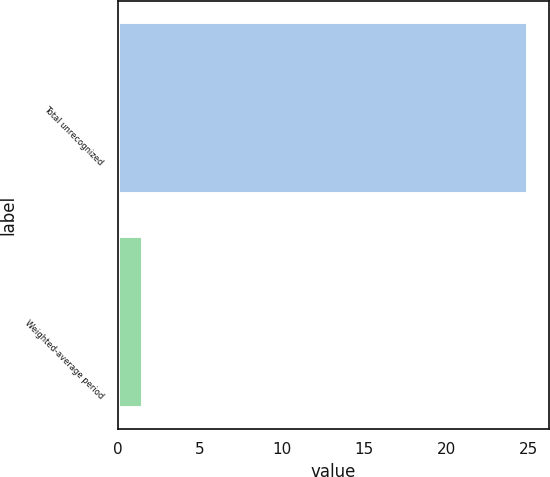Convert chart. <chart><loc_0><loc_0><loc_500><loc_500><bar_chart><fcel>Total unrecognized<fcel>Weighted-average period<nl><fcel>25<fcel>1.5<nl></chart> 